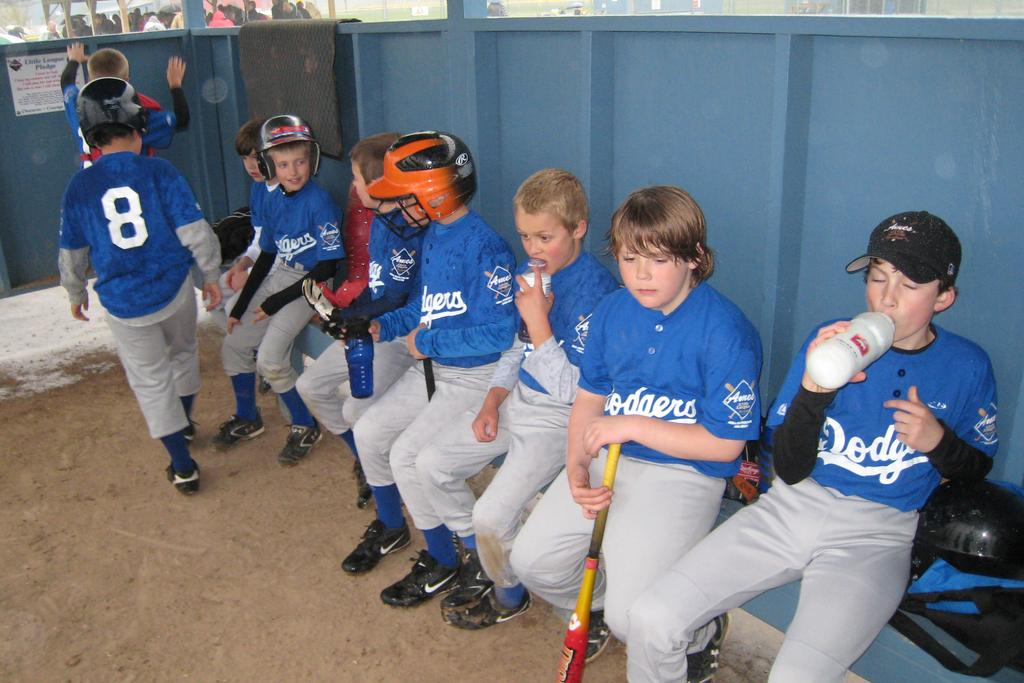<image>
Describe the image concisely. boys in dodgers uniforms sit in their dugout and there is a little league pledge on the wall 